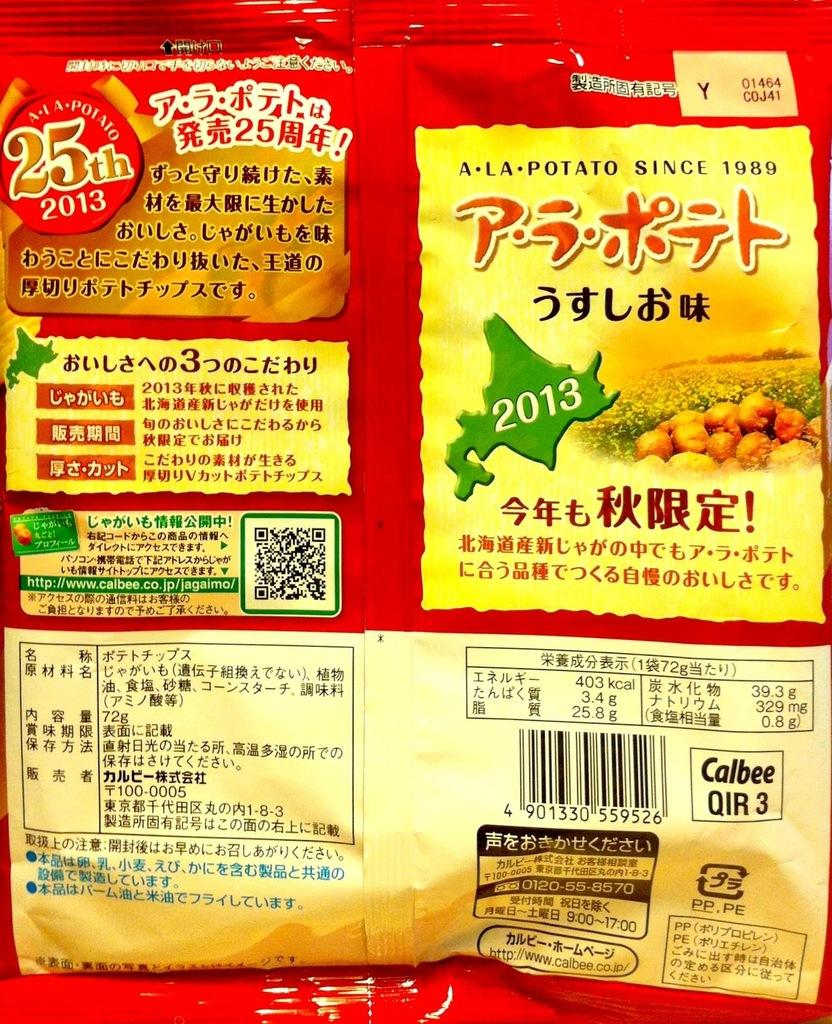What is the color of the packet in the image? The packet in the image is red. What can be found on the surface of the packet? The packet has text on it. What type of identification mark is present on the packet? The packet has a barcode. How much does the item in the packet cost? The packet has a price indicated on it. How many babies are present in the image? There are no babies present in the image. What type of room is depicted in the image? The image does not depict a room; it features a red color packet. 